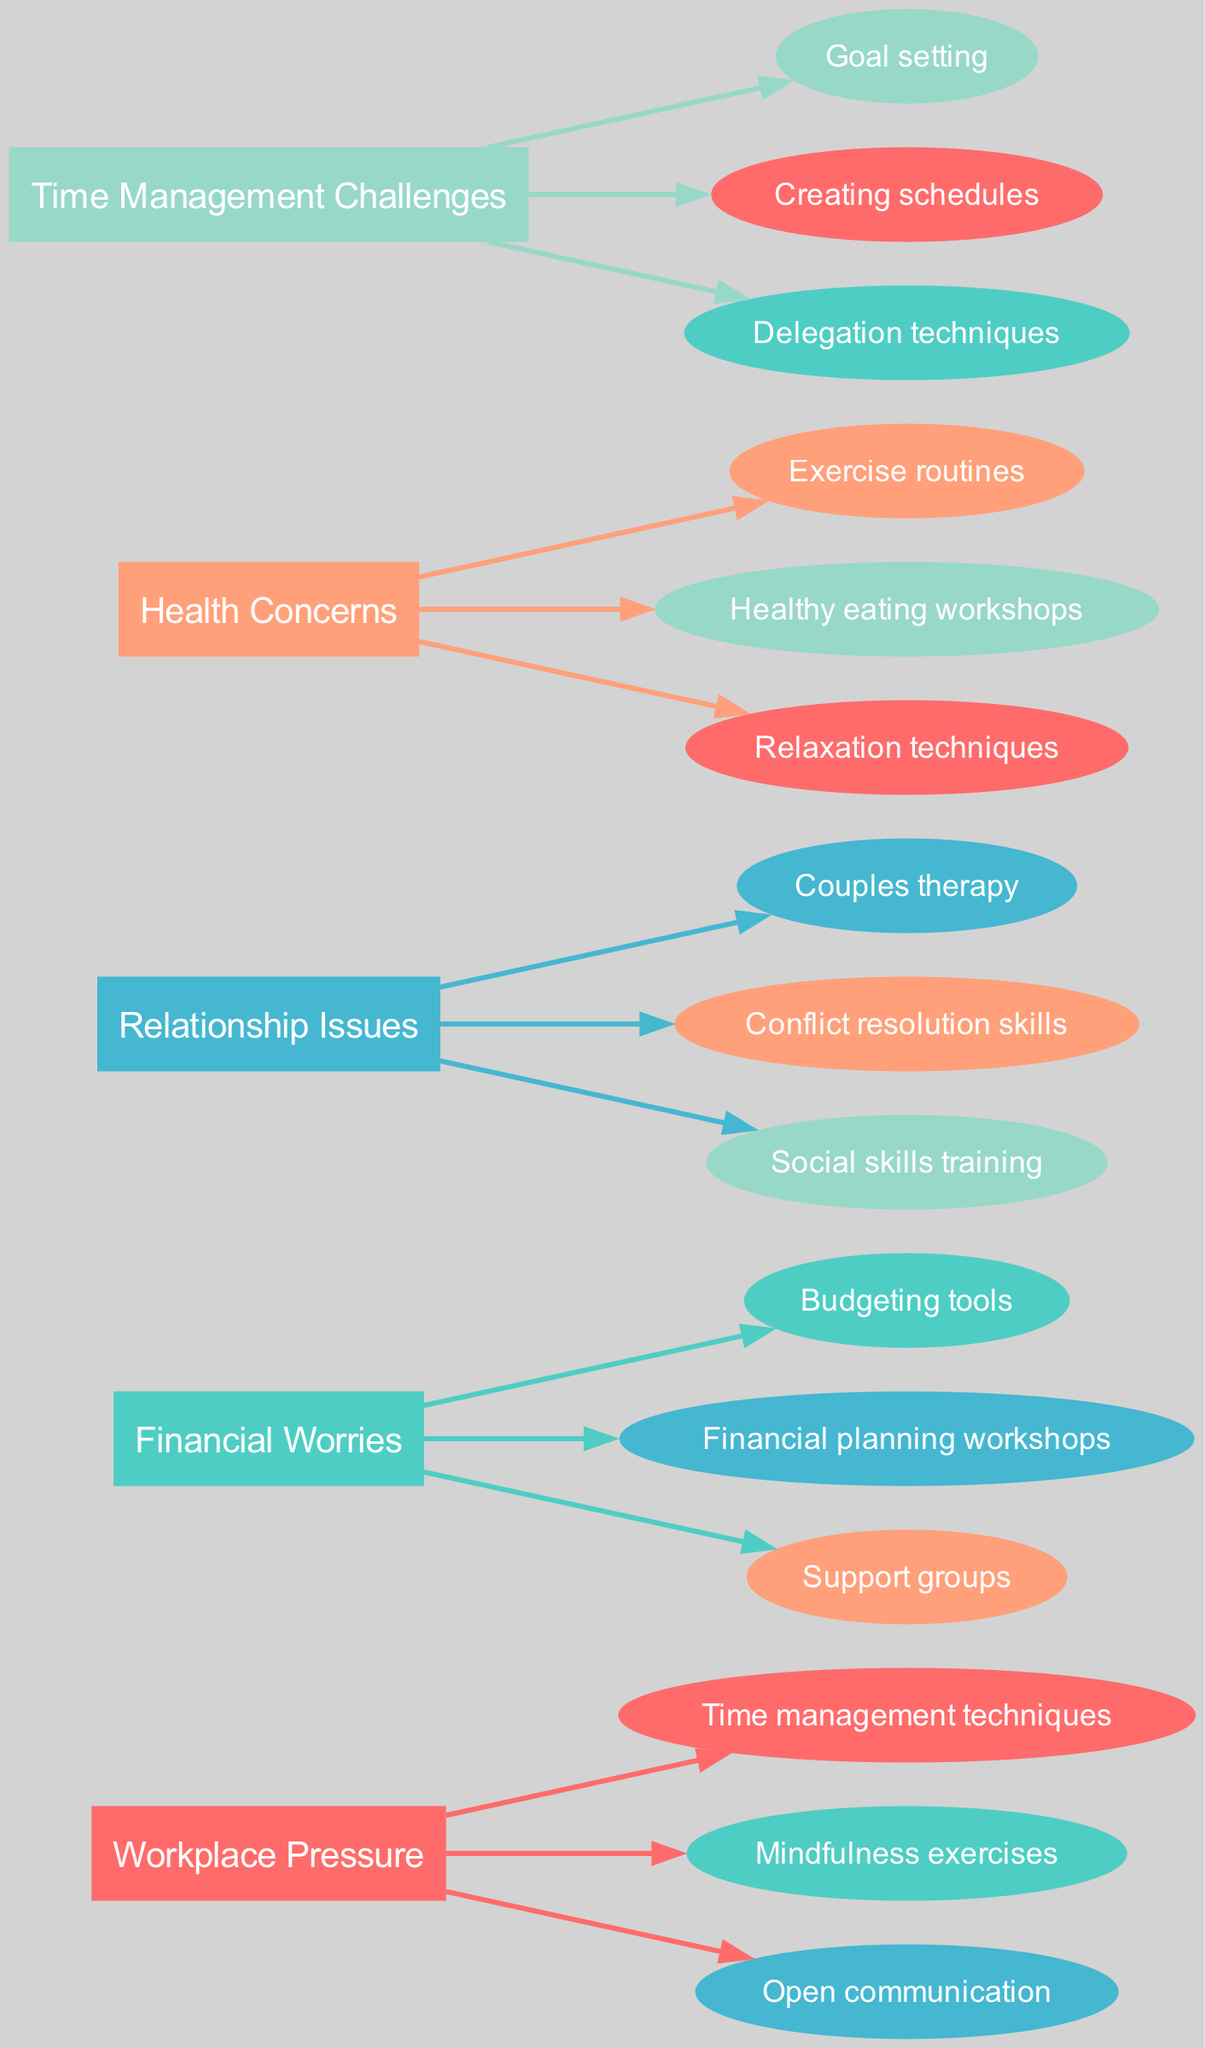What is the first stressor listed in the diagram? The first node for stressors in the diagram represents "Workplace Pressure," which visually appears as the first box on the left.
Answer: Workplace Pressure How many strategies are proposed for addressing Health Concerns? By examining the edges flowing from the "Health Concerns" stressor, we see there are three strategies connected to it: "Exercise routines," "Healthy eating workshops," and "Relaxation techniques."
Answer: 3 Which stressor connects to the strategy "Open communication"? The strategy "Open communication" is connected to the "Workplace Pressure" stressor, as indicated by the edge leading from the "Workplace Pressure" node to this strategy node.
Answer: Workplace Pressure What are the examples listed for Financial Worries? Sourcing from the "Financial Worries" node, the examples are "Debt," "Job instability," and "Unexpected expenses," which each branch from this specific stressor.
Answer: Debt, Job instability, Unexpected expenses Which stressor has the greatest number of coping strategies? By reviewing the strategies linked to each stressor, "Workplace Pressure" has the most connections with three strategies: "Time management techniques," "Mindfulness exercises," and "Open communication."
Answer: Workplace Pressure How many edges connect to the "Conflict resolution skills" strategy? The "Conflict resolution skills" strategy has a single edge that connects it to the "Relationship Issues" stressor, making the count one.
Answer: 1 Which coping strategy is proposed for coping with Time Management Challenges? The strategies linked to "Time Management Challenges" include "Goal setting," "Creating schedules," and "Delegation techniques," making these the coping methods for this stressor.
Answer: Goal setting, Creating schedules, Delegation techniques How many total stressors are shown in the diagram? Counting the stressor nodes present in the diagram, we identify there are five distinct stressors labeled: Workplace Pressure, Financial Worries, Relationship Issues, Health Concerns, and Time Management Challenges.
Answer: 5 Which two stressors are visually distinguished by the same color? Noting the color coding scheme, both "Financial Worries" and "Health Concerns" share the same color, which can be verified by observing the color of their respective nodes in the diagram.
Answer: Financial Worries, Health Concerns 